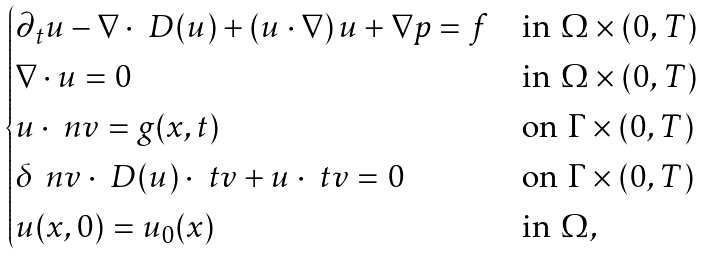<formula> <loc_0><loc_0><loc_500><loc_500>\begin{cases} { \partial _ { t } } { u } - \nabla \cdot \ D ( u ) + ( u \cdot \nabla ) \, u + \nabla p = f & \text {in } \Omega \times ( 0 , T ) \\ \nabla \cdot u = 0 & \text {in } \Omega \times ( 0 , T ) \\ u \cdot \ n v = g ( x , t ) & \text {on } \Gamma \times ( 0 , T ) \\ \delta \, \ n v \cdot \ D ( u ) \cdot \ t v + u \cdot \ t v = 0 & \text {on } \Gamma \times ( 0 , T ) \\ u ( x , 0 ) = u _ { 0 } ( x ) & \text {in } \Omega , \end{cases}</formula> 